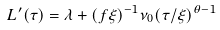Convert formula to latex. <formula><loc_0><loc_0><loc_500><loc_500>L ^ { \prime } ( \tau ) = \lambda + ( f \xi ) ^ { - 1 } \nu _ { 0 } ( \tau / \xi ) ^ { \theta - 1 }</formula> 